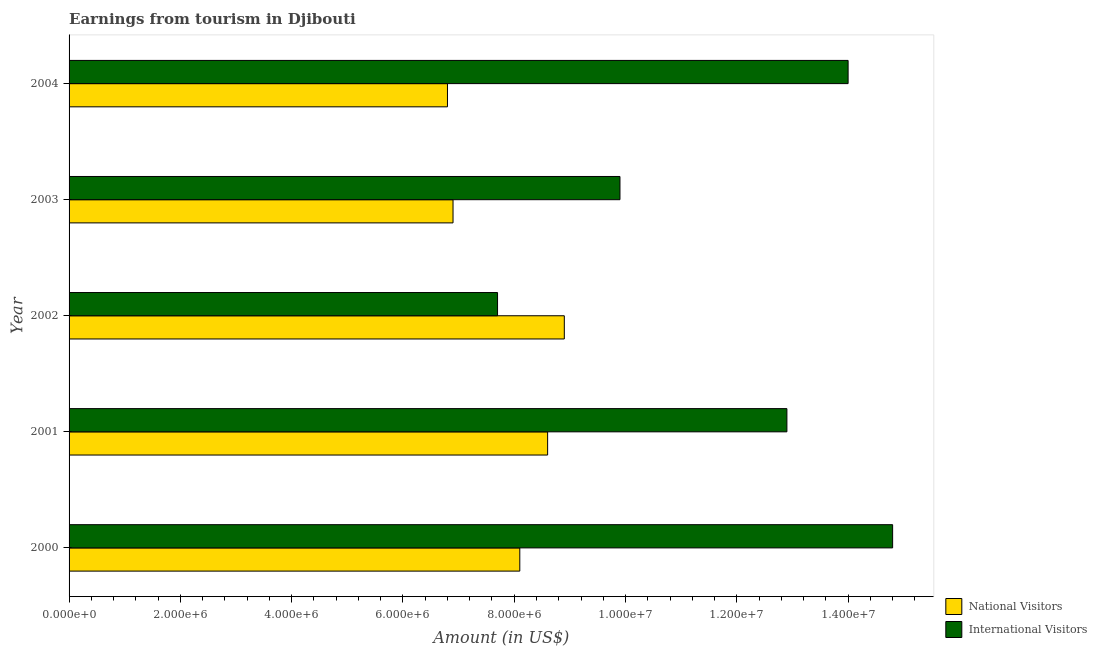How many different coloured bars are there?
Your answer should be compact. 2. Are the number of bars on each tick of the Y-axis equal?
Your answer should be compact. Yes. How many bars are there on the 1st tick from the top?
Your answer should be compact. 2. How many bars are there on the 2nd tick from the bottom?
Provide a short and direct response. 2. What is the label of the 4th group of bars from the top?
Provide a short and direct response. 2001. What is the amount earned from national visitors in 2000?
Make the answer very short. 8.10e+06. Across all years, what is the maximum amount earned from national visitors?
Offer a terse response. 8.90e+06. Across all years, what is the minimum amount earned from international visitors?
Ensure brevity in your answer.  7.70e+06. What is the total amount earned from national visitors in the graph?
Your answer should be very brief. 3.93e+07. What is the difference between the amount earned from national visitors in 2002 and that in 2004?
Provide a short and direct response. 2.10e+06. What is the difference between the amount earned from international visitors in 2003 and the amount earned from national visitors in 2001?
Your answer should be compact. 1.30e+06. What is the average amount earned from international visitors per year?
Provide a short and direct response. 1.19e+07. In the year 2002, what is the difference between the amount earned from national visitors and amount earned from international visitors?
Provide a short and direct response. 1.20e+06. What is the ratio of the amount earned from international visitors in 2003 to that in 2004?
Offer a very short reply. 0.71. What is the difference between the highest and the lowest amount earned from international visitors?
Offer a very short reply. 7.10e+06. What does the 1st bar from the top in 2001 represents?
Offer a terse response. International Visitors. What does the 2nd bar from the bottom in 2000 represents?
Make the answer very short. International Visitors. Are all the bars in the graph horizontal?
Offer a very short reply. Yes. What is the difference between two consecutive major ticks on the X-axis?
Ensure brevity in your answer.  2.00e+06. Does the graph contain any zero values?
Give a very brief answer. No. Does the graph contain grids?
Provide a short and direct response. No. How many legend labels are there?
Make the answer very short. 2. How are the legend labels stacked?
Provide a short and direct response. Vertical. What is the title of the graph?
Give a very brief answer. Earnings from tourism in Djibouti. What is the Amount (in US$) of National Visitors in 2000?
Your response must be concise. 8.10e+06. What is the Amount (in US$) of International Visitors in 2000?
Offer a terse response. 1.48e+07. What is the Amount (in US$) in National Visitors in 2001?
Your answer should be very brief. 8.60e+06. What is the Amount (in US$) in International Visitors in 2001?
Give a very brief answer. 1.29e+07. What is the Amount (in US$) in National Visitors in 2002?
Offer a very short reply. 8.90e+06. What is the Amount (in US$) in International Visitors in 2002?
Give a very brief answer. 7.70e+06. What is the Amount (in US$) in National Visitors in 2003?
Keep it short and to the point. 6.90e+06. What is the Amount (in US$) of International Visitors in 2003?
Offer a very short reply. 9.90e+06. What is the Amount (in US$) of National Visitors in 2004?
Ensure brevity in your answer.  6.80e+06. What is the Amount (in US$) of International Visitors in 2004?
Give a very brief answer. 1.40e+07. Across all years, what is the maximum Amount (in US$) in National Visitors?
Your answer should be very brief. 8.90e+06. Across all years, what is the maximum Amount (in US$) of International Visitors?
Provide a succinct answer. 1.48e+07. Across all years, what is the minimum Amount (in US$) in National Visitors?
Provide a succinct answer. 6.80e+06. Across all years, what is the minimum Amount (in US$) of International Visitors?
Provide a succinct answer. 7.70e+06. What is the total Amount (in US$) of National Visitors in the graph?
Make the answer very short. 3.93e+07. What is the total Amount (in US$) of International Visitors in the graph?
Keep it short and to the point. 5.93e+07. What is the difference between the Amount (in US$) of National Visitors in 2000 and that in 2001?
Offer a very short reply. -5.00e+05. What is the difference between the Amount (in US$) of International Visitors in 2000 and that in 2001?
Your answer should be very brief. 1.90e+06. What is the difference between the Amount (in US$) of National Visitors in 2000 and that in 2002?
Provide a short and direct response. -8.00e+05. What is the difference between the Amount (in US$) in International Visitors in 2000 and that in 2002?
Your answer should be very brief. 7.10e+06. What is the difference between the Amount (in US$) of National Visitors in 2000 and that in 2003?
Provide a short and direct response. 1.20e+06. What is the difference between the Amount (in US$) of International Visitors in 2000 and that in 2003?
Give a very brief answer. 4.90e+06. What is the difference between the Amount (in US$) in National Visitors in 2000 and that in 2004?
Offer a terse response. 1.30e+06. What is the difference between the Amount (in US$) in International Visitors in 2000 and that in 2004?
Give a very brief answer. 8.00e+05. What is the difference between the Amount (in US$) of National Visitors in 2001 and that in 2002?
Make the answer very short. -3.00e+05. What is the difference between the Amount (in US$) in International Visitors in 2001 and that in 2002?
Your answer should be compact. 5.20e+06. What is the difference between the Amount (in US$) in National Visitors in 2001 and that in 2003?
Offer a very short reply. 1.70e+06. What is the difference between the Amount (in US$) in National Visitors in 2001 and that in 2004?
Offer a very short reply. 1.80e+06. What is the difference between the Amount (in US$) in International Visitors in 2001 and that in 2004?
Offer a terse response. -1.10e+06. What is the difference between the Amount (in US$) of International Visitors in 2002 and that in 2003?
Provide a succinct answer. -2.20e+06. What is the difference between the Amount (in US$) of National Visitors in 2002 and that in 2004?
Your answer should be compact. 2.10e+06. What is the difference between the Amount (in US$) of International Visitors in 2002 and that in 2004?
Offer a terse response. -6.30e+06. What is the difference between the Amount (in US$) in International Visitors in 2003 and that in 2004?
Your answer should be very brief. -4.10e+06. What is the difference between the Amount (in US$) in National Visitors in 2000 and the Amount (in US$) in International Visitors in 2001?
Your answer should be compact. -4.80e+06. What is the difference between the Amount (in US$) of National Visitors in 2000 and the Amount (in US$) of International Visitors in 2002?
Make the answer very short. 4.00e+05. What is the difference between the Amount (in US$) in National Visitors in 2000 and the Amount (in US$) in International Visitors in 2003?
Provide a short and direct response. -1.80e+06. What is the difference between the Amount (in US$) in National Visitors in 2000 and the Amount (in US$) in International Visitors in 2004?
Your answer should be very brief. -5.90e+06. What is the difference between the Amount (in US$) of National Visitors in 2001 and the Amount (in US$) of International Visitors in 2002?
Provide a short and direct response. 9.00e+05. What is the difference between the Amount (in US$) in National Visitors in 2001 and the Amount (in US$) in International Visitors in 2003?
Make the answer very short. -1.30e+06. What is the difference between the Amount (in US$) of National Visitors in 2001 and the Amount (in US$) of International Visitors in 2004?
Give a very brief answer. -5.40e+06. What is the difference between the Amount (in US$) in National Visitors in 2002 and the Amount (in US$) in International Visitors in 2004?
Your answer should be compact. -5.10e+06. What is the difference between the Amount (in US$) of National Visitors in 2003 and the Amount (in US$) of International Visitors in 2004?
Ensure brevity in your answer.  -7.10e+06. What is the average Amount (in US$) of National Visitors per year?
Ensure brevity in your answer.  7.86e+06. What is the average Amount (in US$) in International Visitors per year?
Your answer should be very brief. 1.19e+07. In the year 2000, what is the difference between the Amount (in US$) in National Visitors and Amount (in US$) in International Visitors?
Give a very brief answer. -6.70e+06. In the year 2001, what is the difference between the Amount (in US$) of National Visitors and Amount (in US$) of International Visitors?
Your answer should be compact. -4.30e+06. In the year 2002, what is the difference between the Amount (in US$) in National Visitors and Amount (in US$) in International Visitors?
Your answer should be very brief. 1.20e+06. In the year 2003, what is the difference between the Amount (in US$) of National Visitors and Amount (in US$) of International Visitors?
Ensure brevity in your answer.  -3.00e+06. In the year 2004, what is the difference between the Amount (in US$) in National Visitors and Amount (in US$) in International Visitors?
Your answer should be very brief. -7.20e+06. What is the ratio of the Amount (in US$) of National Visitors in 2000 to that in 2001?
Provide a succinct answer. 0.94. What is the ratio of the Amount (in US$) in International Visitors in 2000 to that in 2001?
Give a very brief answer. 1.15. What is the ratio of the Amount (in US$) of National Visitors in 2000 to that in 2002?
Offer a terse response. 0.91. What is the ratio of the Amount (in US$) of International Visitors in 2000 to that in 2002?
Give a very brief answer. 1.92. What is the ratio of the Amount (in US$) in National Visitors in 2000 to that in 2003?
Give a very brief answer. 1.17. What is the ratio of the Amount (in US$) of International Visitors in 2000 to that in 2003?
Your answer should be very brief. 1.49. What is the ratio of the Amount (in US$) in National Visitors in 2000 to that in 2004?
Offer a very short reply. 1.19. What is the ratio of the Amount (in US$) of International Visitors in 2000 to that in 2004?
Provide a succinct answer. 1.06. What is the ratio of the Amount (in US$) in National Visitors in 2001 to that in 2002?
Offer a very short reply. 0.97. What is the ratio of the Amount (in US$) in International Visitors in 2001 to that in 2002?
Ensure brevity in your answer.  1.68. What is the ratio of the Amount (in US$) in National Visitors in 2001 to that in 2003?
Give a very brief answer. 1.25. What is the ratio of the Amount (in US$) in International Visitors in 2001 to that in 2003?
Your response must be concise. 1.3. What is the ratio of the Amount (in US$) of National Visitors in 2001 to that in 2004?
Your answer should be compact. 1.26. What is the ratio of the Amount (in US$) of International Visitors in 2001 to that in 2004?
Your answer should be very brief. 0.92. What is the ratio of the Amount (in US$) in National Visitors in 2002 to that in 2003?
Offer a very short reply. 1.29. What is the ratio of the Amount (in US$) of National Visitors in 2002 to that in 2004?
Provide a succinct answer. 1.31. What is the ratio of the Amount (in US$) of International Visitors in 2002 to that in 2004?
Your answer should be compact. 0.55. What is the ratio of the Amount (in US$) of National Visitors in 2003 to that in 2004?
Provide a short and direct response. 1.01. What is the ratio of the Amount (in US$) of International Visitors in 2003 to that in 2004?
Provide a succinct answer. 0.71. What is the difference between the highest and the second highest Amount (in US$) of International Visitors?
Your answer should be compact. 8.00e+05. What is the difference between the highest and the lowest Amount (in US$) of National Visitors?
Your response must be concise. 2.10e+06. What is the difference between the highest and the lowest Amount (in US$) in International Visitors?
Offer a very short reply. 7.10e+06. 